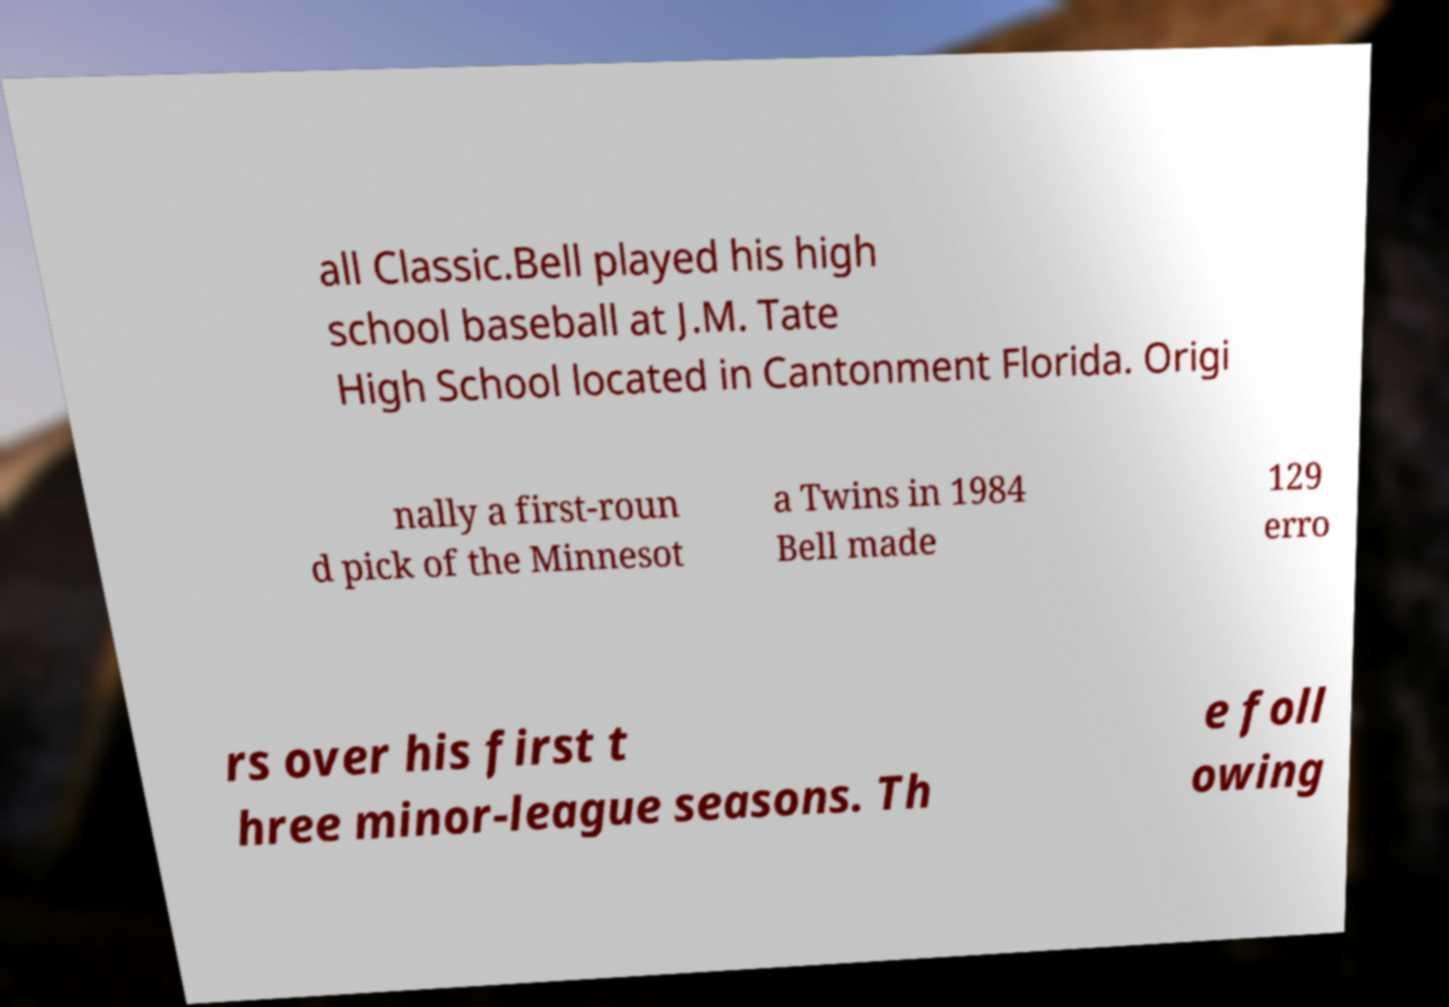Can you read and provide the text displayed in the image?This photo seems to have some interesting text. Can you extract and type it out for me? all Classic.Bell played his high school baseball at J.M. Tate High School located in Cantonment Florida. Origi nally a first-roun d pick of the Minnesot a Twins in 1984 Bell made 129 erro rs over his first t hree minor-league seasons. Th e foll owing 